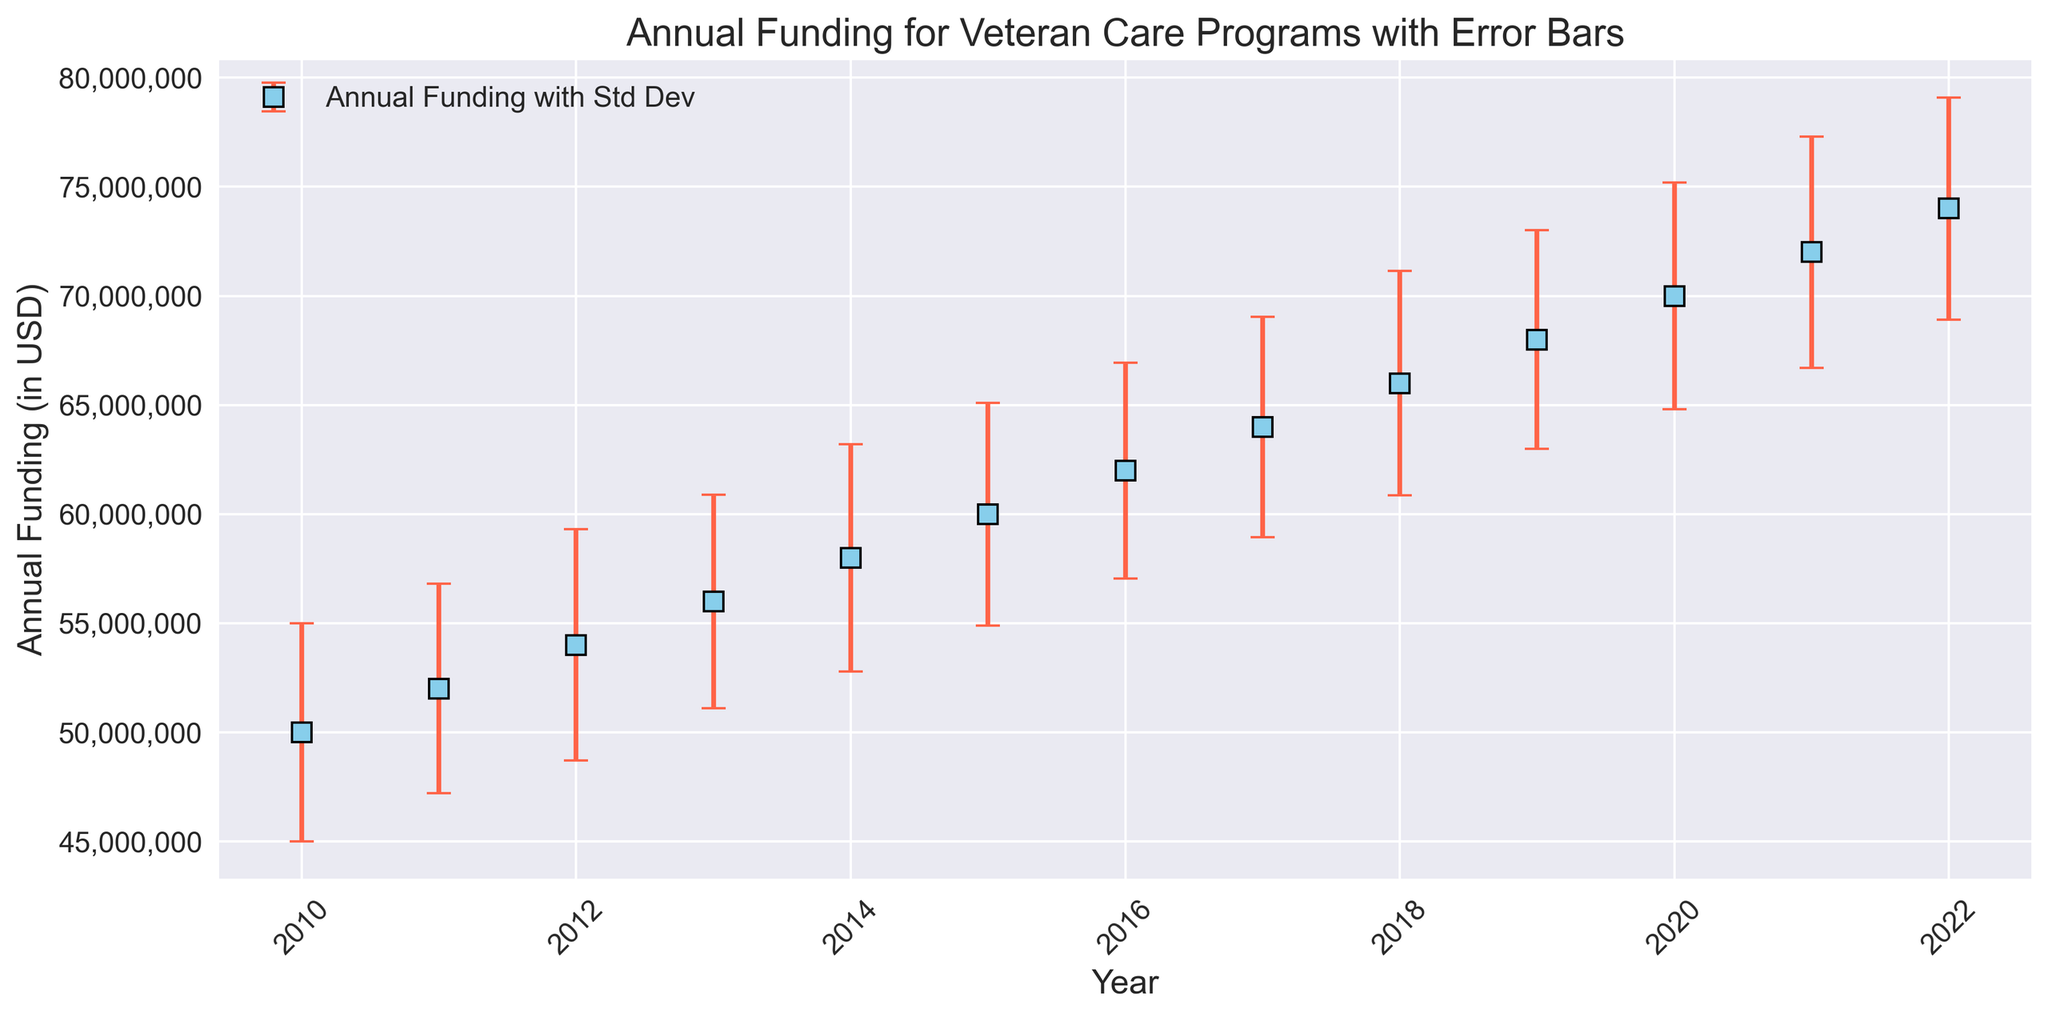What's the general trend of annual funding from 2010 to 2022? The annual funding increases every year from 2010 to 2022. You can observe an upward trend in the plotted data points over the given years, indicating steadily increasing funding for veteran care programs.
Answer: Increasing Which year had the highest annual funding? To find the year with the highest funding, look at the data points plotted highest on the y-axis. The highest funding is $74,000,000 in the year 2022.
Answer: 2022 How does the standard deviation vary over the years? The standard deviation values are shown as error bars in the figure. The error bars' lengths don't show any drastically increasing or decreasing trend, indicating roughly consistent variability each year.
Answer: Consistent What's the difference in annual funding between the years 2015 and 2020? Look at the funding for 2015 and 2020; 2020 funding is $70,000,000 and 2015 funding is $60,000,000. The difference is $70,000,000 - $60,000,000 = $10,000,000.
Answer: $10,000,000 Which year experienced the largest increase in annual funding compared to the previous year? Calculate the yearly funding increases and compare them. The largest increase is from 2019 to 2020, where the funding increased from $68,000,000 to $70,000,000, a difference of $2,000,000.
Answer: 2020 What is the average annual funding over the period shown? Sum the annual funding from 2010 to 2022 and divide by the number of years. For this dataset, the sum of all funding values is $810,000,000. There are 13 years, so on average, $810,000,000 / 13 = $62,307,692.31.
Answer: $62,307,692.31 Are there any years where the funding decreased compared to the previous year? Check each subsequent year's funding; in this plot, each year's funding is higher than the previous year, so no decreases are observed.
Answer: No Which year had the lowest annual funding and how much was it? The lowest funding is at the beginning of the figure. The year 2010 had the lowest funding, which was $50,000,000.
Answer: 2010, $50,000,000 What visual marker is used to represent the annual funding data points? The data points for annual funding are represented by square markers.
Answer: Squares 